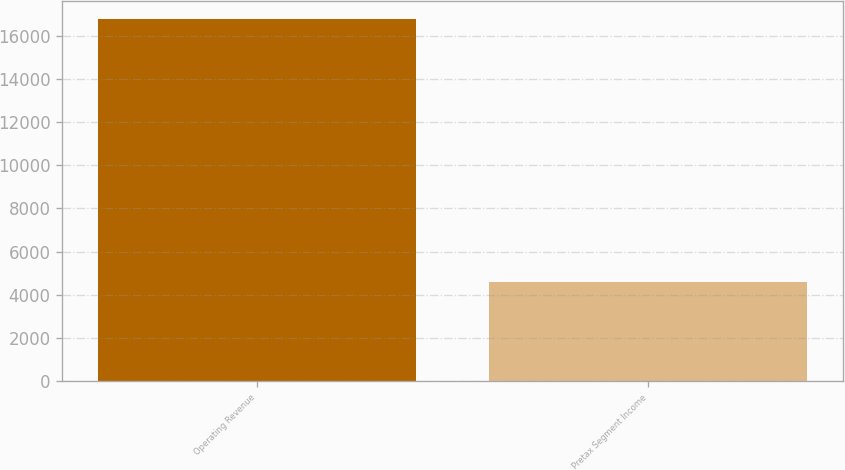<chart> <loc_0><loc_0><loc_500><loc_500><bar_chart><fcel>Operating Revenue<fcel>Pretax Segment Income<nl><fcel>16767<fcel>4603<nl></chart> 